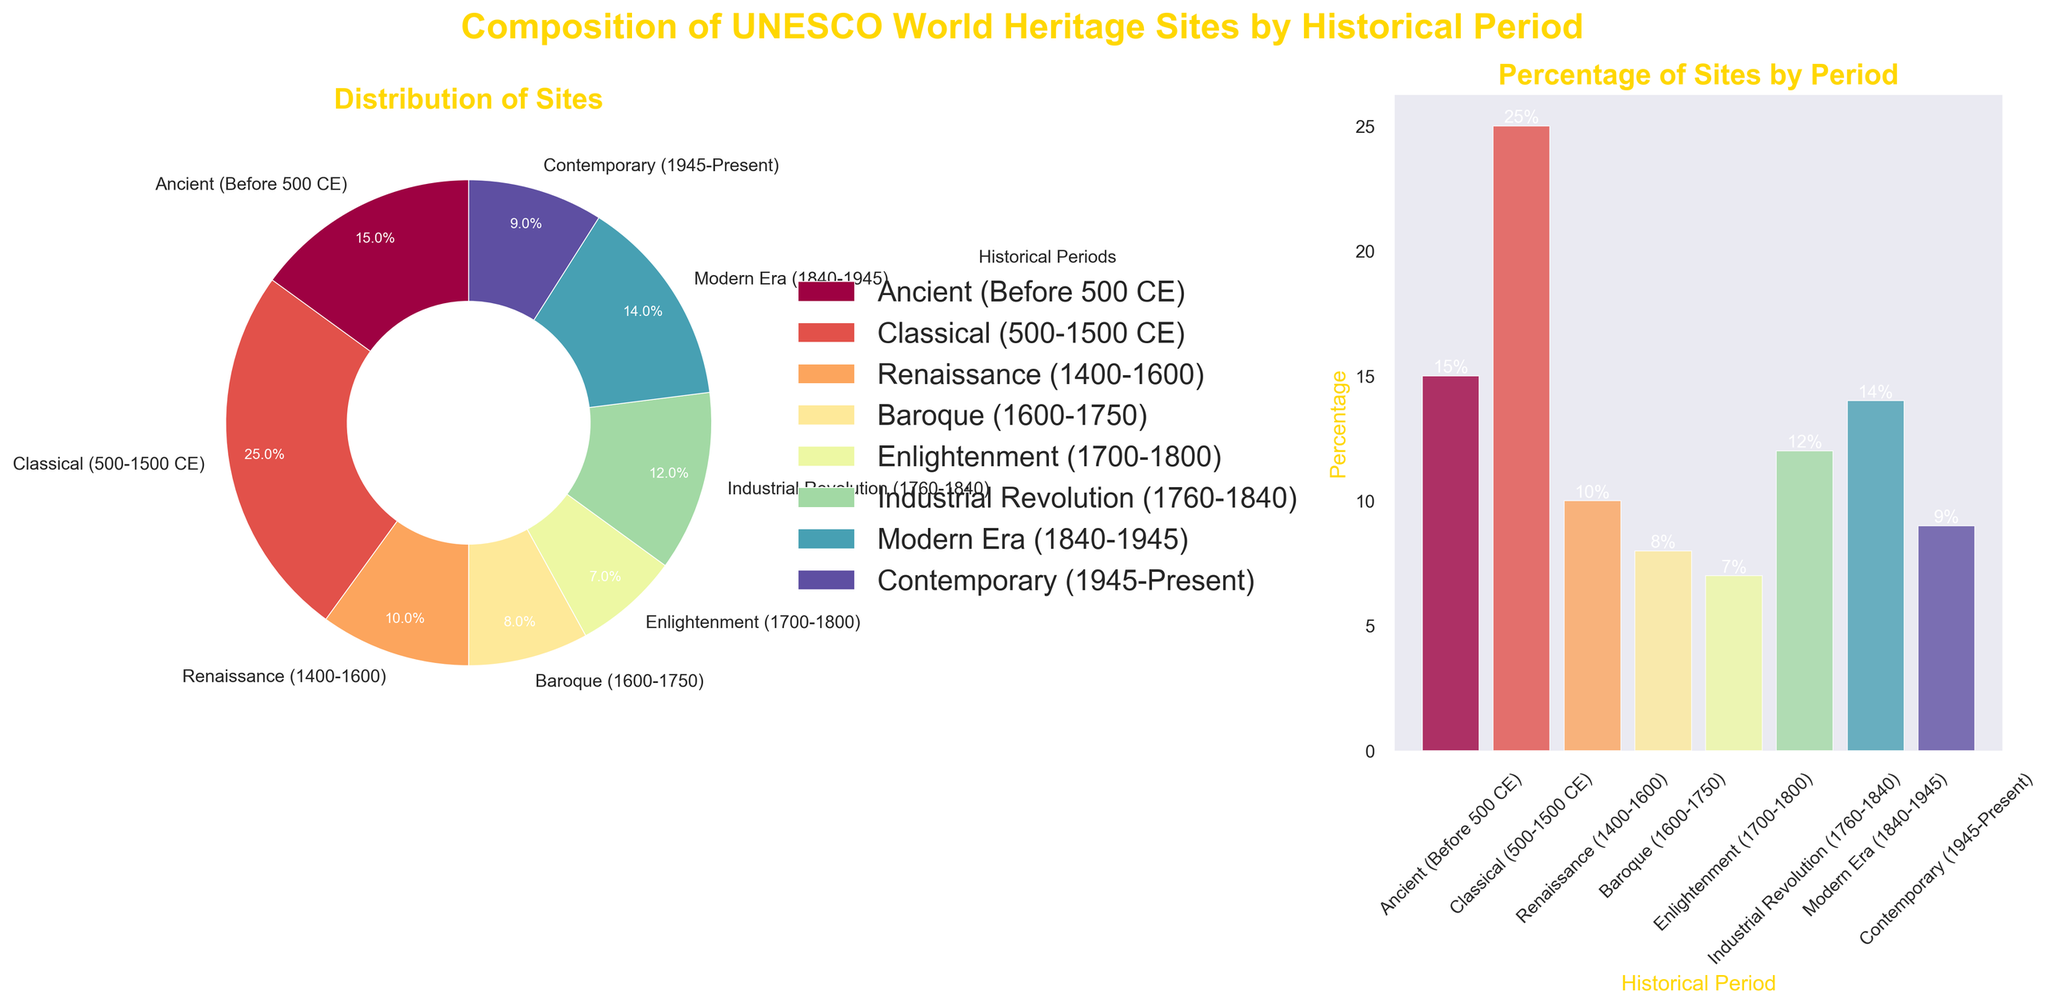what historical periods have a combined percentage greater than 30%? To determine this, sum the percentages of the periods. Adding the percentages for Classical (25%) and Ancient (15%) results in 40%, which is greater than 30%. Hence, these periods combined exceed 30%.
Answer: Classical and Ancient which historical period has the smallest representation in UNESCO World Heritage Sites? By examining both the pie and bar charts, the Enlightenment period has the smallest percentage at 7%.
Answer: Enlightenment compare the representation of the Renaissance to the Industrial Revolution. The percentage of sites from the Renaissance is 10%, while the Industrial Revolution has 12%. Thus, the Industrial Revolution has a higher representation.
Answer: Industrial Revolution > Renaissance how does the Modern Era compare visually to the Ancient period? Visually, in both the pie and bar charts, the Modern Era has a smaller proportion (14%) than the Ancient period (15%). They are quite close, but the Ancient period is slightly larger.
Answer: Modern Era < Ancient period if you combine the percentages of Baroque and Contemporary periods, what do you get? Adding the percentages of the Baroque (8%) and Contemporary (9%) periods results in a combined percentage of 17%.
Answer: 17% what is the total percentage of UNESCO World Heritage Sites from the Industrial Revolution onwards? Sum the percentages for the Industrial Revolution (12%), Modern Era (14%), and Contemporary (9%) periods. Adding these gives 12% + 14% + 9% = 35%.
Answer: 35% which period comes second after the Classical period in terms of percentage? From the figure, the Classical period has 25%, and the next highest is the Ancient period with 15%.
Answer: Ancient do any periods have equal representation, and if so, which ones? Comparing the percentages, no two periods have the same percentage.
Answer: None which periods together make up less than 20% of the world heritage sites? Summing the periods with smaller percentages: Baroque (8%), Enlightenment (7%), and Contemporary (9%). Combining these gives 8% + 7% = 15%, and 15% < 20%. Note: Contemporary alone is 9% which is less than 20%.
Answer: Baroque, Enlightenment, Contemporary what are the visual differences in bar heights between the Classical and Renaissance periods? The bar representing the Classical period is significantly taller than the Renaissance period, reflecting their respective percentages of 25% and 10%.
Answer: Classical bar > Renaissance bar 